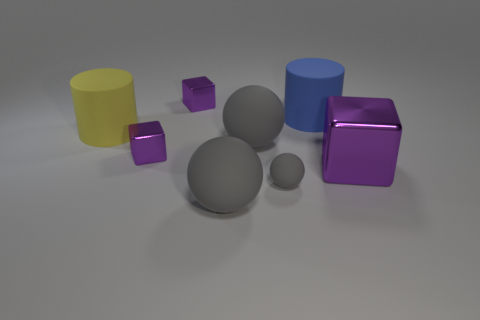How many purple cubes must be subtracted to get 1 purple cubes? 2 Add 2 small rubber objects. How many objects exist? 10 Subtract all balls. How many objects are left? 5 Subtract all yellow cylinders. Subtract all balls. How many objects are left? 4 Add 1 big yellow rubber objects. How many big yellow rubber objects are left? 2 Add 4 tiny shiny cubes. How many tiny shiny cubes exist? 6 Subtract 0 blue blocks. How many objects are left? 8 